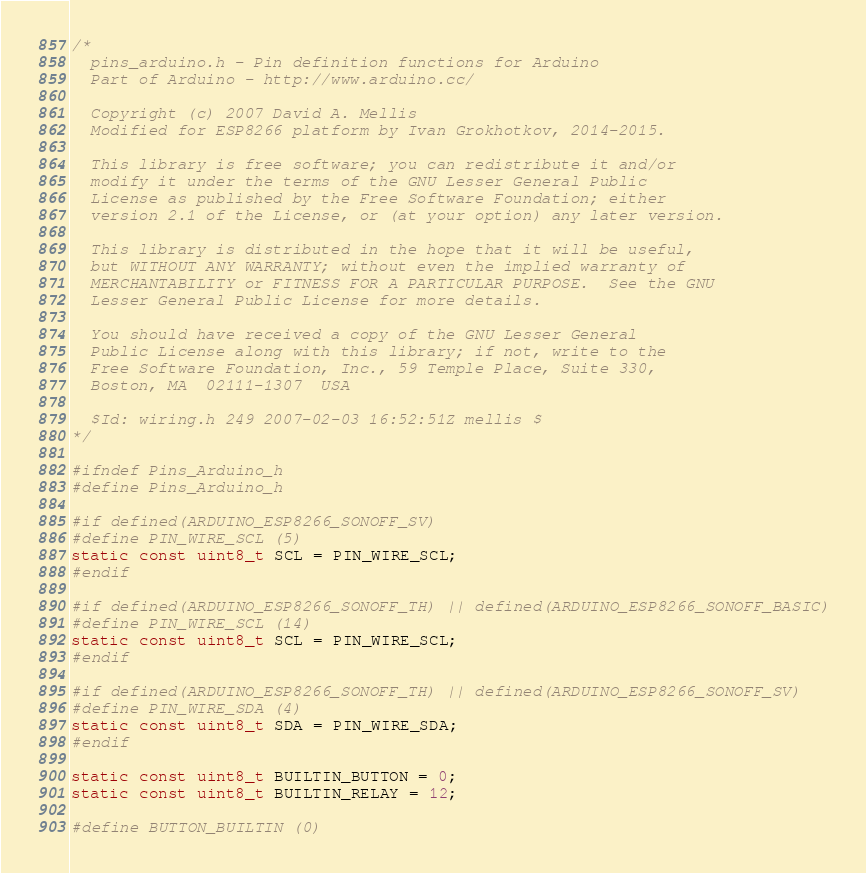<code> <loc_0><loc_0><loc_500><loc_500><_C_>/*
  pins_arduino.h - Pin definition functions for Arduino
  Part of Arduino - http://www.arduino.cc/

  Copyright (c) 2007 David A. Mellis
  Modified for ESP8266 platform by Ivan Grokhotkov, 2014-2015.

  This library is free software; you can redistribute it and/or
  modify it under the terms of the GNU Lesser General Public
  License as published by the Free Software Foundation; either
  version 2.1 of the License, or (at your option) any later version.

  This library is distributed in the hope that it will be useful,
  but WITHOUT ANY WARRANTY; without even the implied warranty of
  MERCHANTABILITY or FITNESS FOR A PARTICULAR PURPOSE.  See the GNU
  Lesser General Public License for more details.

  You should have received a copy of the GNU Lesser General
  Public License along with this library; if not, write to the
  Free Software Foundation, Inc., 59 Temple Place, Suite 330,
  Boston, MA  02111-1307  USA

  $Id: wiring.h 249 2007-02-03 16:52:51Z mellis $
*/

#ifndef Pins_Arduino_h
#define Pins_Arduino_h

#if defined(ARDUINO_ESP8266_SONOFF_SV)
#define PIN_WIRE_SCL (5)
static const uint8_t SCL = PIN_WIRE_SCL;
#endif

#if defined(ARDUINO_ESP8266_SONOFF_TH) || defined(ARDUINO_ESP8266_SONOFF_BASIC)
#define PIN_WIRE_SCL (14)
static const uint8_t SCL = PIN_WIRE_SCL;
#endif

#if defined(ARDUINO_ESP8266_SONOFF_TH) || defined(ARDUINO_ESP8266_SONOFF_SV)
#define PIN_WIRE_SDA (4)
static const uint8_t SDA = PIN_WIRE_SDA;
#endif

static const uint8_t BUILTIN_BUTTON = 0;
static const uint8_t BUILTIN_RELAY = 12;

#define BUTTON_BUILTIN (0)</code> 